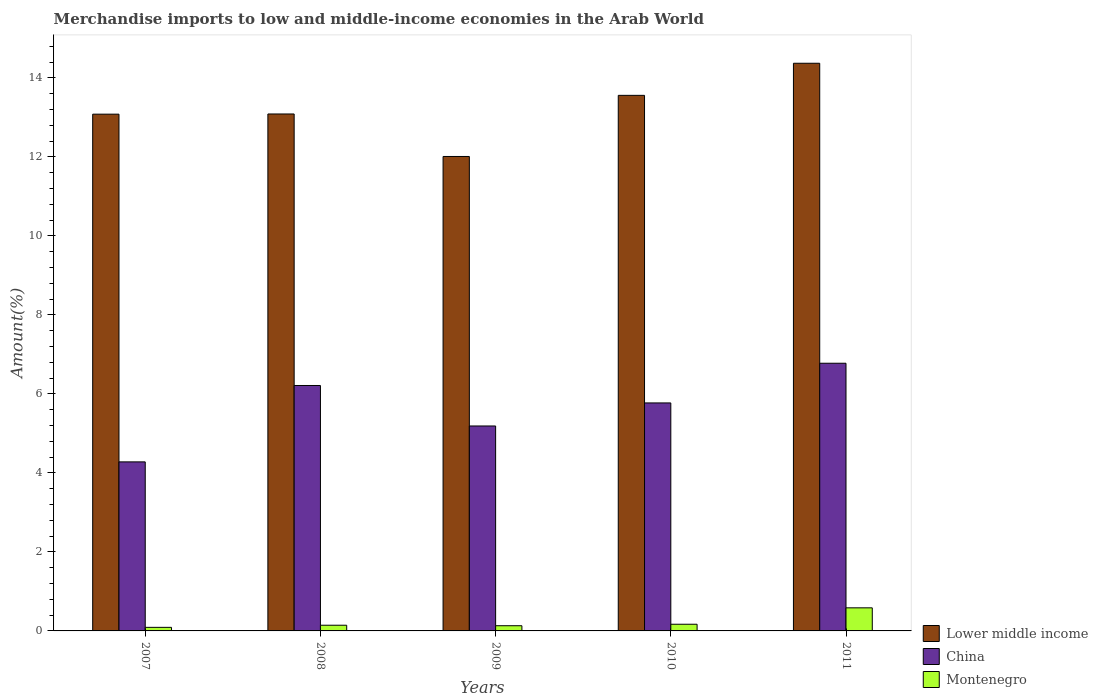How many different coloured bars are there?
Make the answer very short. 3. How many groups of bars are there?
Keep it short and to the point. 5. Are the number of bars per tick equal to the number of legend labels?
Your response must be concise. Yes. Are the number of bars on each tick of the X-axis equal?
Your answer should be compact. Yes. What is the label of the 2nd group of bars from the left?
Offer a terse response. 2008. In how many cases, is the number of bars for a given year not equal to the number of legend labels?
Provide a succinct answer. 0. What is the percentage of amount earned from merchandise imports in China in 2011?
Give a very brief answer. 6.78. Across all years, what is the maximum percentage of amount earned from merchandise imports in Lower middle income?
Offer a terse response. 14.37. Across all years, what is the minimum percentage of amount earned from merchandise imports in China?
Keep it short and to the point. 4.28. In which year was the percentage of amount earned from merchandise imports in China minimum?
Provide a short and direct response. 2007. What is the total percentage of amount earned from merchandise imports in Montenegro in the graph?
Your answer should be very brief. 1.12. What is the difference between the percentage of amount earned from merchandise imports in Lower middle income in 2007 and that in 2009?
Make the answer very short. 1.07. What is the difference between the percentage of amount earned from merchandise imports in Montenegro in 2008 and the percentage of amount earned from merchandise imports in Lower middle income in 2009?
Offer a terse response. -11.86. What is the average percentage of amount earned from merchandise imports in China per year?
Make the answer very short. 5.64. In the year 2008, what is the difference between the percentage of amount earned from merchandise imports in Lower middle income and percentage of amount earned from merchandise imports in China?
Give a very brief answer. 6.87. What is the ratio of the percentage of amount earned from merchandise imports in Montenegro in 2007 to that in 2010?
Give a very brief answer. 0.54. Is the percentage of amount earned from merchandise imports in Lower middle income in 2009 less than that in 2011?
Provide a short and direct response. Yes. What is the difference between the highest and the second highest percentage of amount earned from merchandise imports in Montenegro?
Offer a terse response. 0.42. What is the difference between the highest and the lowest percentage of amount earned from merchandise imports in Lower middle income?
Offer a very short reply. 2.36. Is the sum of the percentage of amount earned from merchandise imports in Lower middle income in 2007 and 2011 greater than the maximum percentage of amount earned from merchandise imports in Montenegro across all years?
Give a very brief answer. Yes. What does the 3rd bar from the left in 2008 represents?
Provide a succinct answer. Montenegro. What does the 3rd bar from the right in 2011 represents?
Your answer should be very brief. Lower middle income. Are all the bars in the graph horizontal?
Provide a short and direct response. No. How many years are there in the graph?
Keep it short and to the point. 5. What is the difference between two consecutive major ticks on the Y-axis?
Keep it short and to the point. 2. Where does the legend appear in the graph?
Your answer should be compact. Bottom right. What is the title of the graph?
Your answer should be compact. Merchandise imports to low and middle-income economies in the Arab World. What is the label or title of the Y-axis?
Your response must be concise. Amount(%). What is the Amount(%) of Lower middle income in 2007?
Ensure brevity in your answer.  13.08. What is the Amount(%) in China in 2007?
Provide a short and direct response. 4.28. What is the Amount(%) in Montenegro in 2007?
Your answer should be compact. 0.09. What is the Amount(%) of Lower middle income in 2008?
Your response must be concise. 13.08. What is the Amount(%) of China in 2008?
Ensure brevity in your answer.  6.21. What is the Amount(%) in Montenegro in 2008?
Your response must be concise. 0.14. What is the Amount(%) in Lower middle income in 2009?
Provide a succinct answer. 12.01. What is the Amount(%) of China in 2009?
Give a very brief answer. 5.19. What is the Amount(%) in Montenegro in 2009?
Give a very brief answer. 0.13. What is the Amount(%) of Lower middle income in 2010?
Keep it short and to the point. 13.56. What is the Amount(%) of China in 2010?
Ensure brevity in your answer.  5.77. What is the Amount(%) in Montenegro in 2010?
Offer a terse response. 0.17. What is the Amount(%) of Lower middle income in 2011?
Provide a succinct answer. 14.37. What is the Amount(%) in China in 2011?
Keep it short and to the point. 6.78. What is the Amount(%) of Montenegro in 2011?
Your answer should be compact. 0.58. Across all years, what is the maximum Amount(%) in Lower middle income?
Your answer should be compact. 14.37. Across all years, what is the maximum Amount(%) in China?
Your response must be concise. 6.78. Across all years, what is the maximum Amount(%) of Montenegro?
Keep it short and to the point. 0.58. Across all years, what is the minimum Amount(%) of Lower middle income?
Ensure brevity in your answer.  12.01. Across all years, what is the minimum Amount(%) of China?
Your response must be concise. 4.28. Across all years, what is the minimum Amount(%) in Montenegro?
Provide a succinct answer. 0.09. What is the total Amount(%) of Lower middle income in the graph?
Keep it short and to the point. 66.1. What is the total Amount(%) of China in the graph?
Your answer should be compact. 28.22. What is the total Amount(%) in Montenegro in the graph?
Ensure brevity in your answer.  1.12. What is the difference between the Amount(%) of Lower middle income in 2007 and that in 2008?
Your answer should be very brief. -0. What is the difference between the Amount(%) of China in 2007 and that in 2008?
Keep it short and to the point. -1.93. What is the difference between the Amount(%) in Montenegro in 2007 and that in 2008?
Provide a succinct answer. -0.05. What is the difference between the Amount(%) in Lower middle income in 2007 and that in 2009?
Your response must be concise. 1.07. What is the difference between the Amount(%) in China in 2007 and that in 2009?
Provide a succinct answer. -0.91. What is the difference between the Amount(%) of Montenegro in 2007 and that in 2009?
Keep it short and to the point. -0.04. What is the difference between the Amount(%) of Lower middle income in 2007 and that in 2010?
Offer a very short reply. -0.48. What is the difference between the Amount(%) of China in 2007 and that in 2010?
Offer a terse response. -1.49. What is the difference between the Amount(%) in Montenegro in 2007 and that in 2010?
Offer a terse response. -0.08. What is the difference between the Amount(%) in Lower middle income in 2007 and that in 2011?
Your answer should be very brief. -1.29. What is the difference between the Amount(%) of China in 2007 and that in 2011?
Provide a short and direct response. -2.5. What is the difference between the Amount(%) of Montenegro in 2007 and that in 2011?
Make the answer very short. -0.49. What is the difference between the Amount(%) in Lower middle income in 2008 and that in 2009?
Your response must be concise. 1.08. What is the difference between the Amount(%) of Montenegro in 2008 and that in 2009?
Provide a succinct answer. 0.01. What is the difference between the Amount(%) in Lower middle income in 2008 and that in 2010?
Ensure brevity in your answer.  -0.47. What is the difference between the Amount(%) of China in 2008 and that in 2010?
Ensure brevity in your answer.  0.44. What is the difference between the Amount(%) in Montenegro in 2008 and that in 2010?
Your answer should be very brief. -0.02. What is the difference between the Amount(%) in Lower middle income in 2008 and that in 2011?
Provide a succinct answer. -1.28. What is the difference between the Amount(%) in China in 2008 and that in 2011?
Offer a terse response. -0.56. What is the difference between the Amount(%) in Montenegro in 2008 and that in 2011?
Your answer should be very brief. -0.44. What is the difference between the Amount(%) in Lower middle income in 2009 and that in 2010?
Give a very brief answer. -1.55. What is the difference between the Amount(%) in China in 2009 and that in 2010?
Offer a terse response. -0.58. What is the difference between the Amount(%) of Montenegro in 2009 and that in 2010?
Provide a short and direct response. -0.04. What is the difference between the Amount(%) in Lower middle income in 2009 and that in 2011?
Provide a succinct answer. -2.36. What is the difference between the Amount(%) in China in 2009 and that in 2011?
Give a very brief answer. -1.59. What is the difference between the Amount(%) of Montenegro in 2009 and that in 2011?
Offer a terse response. -0.45. What is the difference between the Amount(%) in Lower middle income in 2010 and that in 2011?
Offer a very short reply. -0.81. What is the difference between the Amount(%) of China in 2010 and that in 2011?
Offer a terse response. -1. What is the difference between the Amount(%) of Montenegro in 2010 and that in 2011?
Make the answer very short. -0.42. What is the difference between the Amount(%) in Lower middle income in 2007 and the Amount(%) in China in 2008?
Your answer should be compact. 6.87. What is the difference between the Amount(%) in Lower middle income in 2007 and the Amount(%) in Montenegro in 2008?
Offer a very short reply. 12.94. What is the difference between the Amount(%) of China in 2007 and the Amount(%) of Montenegro in 2008?
Make the answer very short. 4.13. What is the difference between the Amount(%) of Lower middle income in 2007 and the Amount(%) of China in 2009?
Offer a very short reply. 7.89. What is the difference between the Amount(%) in Lower middle income in 2007 and the Amount(%) in Montenegro in 2009?
Your response must be concise. 12.95. What is the difference between the Amount(%) of China in 2007 and the Amount(%) of Montenegro in 2009?
Make the answer very short. 4.15. What is the difference between the Amount(%) of Lower middle income in 2007 and the Amount(%) of China in 2010?
Provide a short and direct response. 7.31. What is the difference between the Amount(%) of Lower middle income in 2007 and the Amount(%) of Montenegro in 2010?
Your response must be concise. 12.91. What is the difference between the Amount(%) of China in 2007 and the Amount(%) of Montenegro in 2010?
Provide a short and direct response. 4.11. What is the difference between the Amount(%) of Lower middle income in 2007 and the Amount(%) of China in 2011?
Provide a succinct answer. 6.3. What is the difference between the Amount(%) of Lower middle income in 2007 and the Amount(%) of Montenegro in 2011?
Your response must be concise. 12.5. What is the difference between the Amount(%) of China in 2007 and the Amount(%) of Montenegro in 2011?
Your answer should be compact. 3.69. What is the difference between the Amount(%) of Lower middle income in 2008 and the Amount(%) of China in 2009?
Provide a succinct answer. 7.9. What is the difference between the Amount(%) of Lower middle income in 2008 and the Amount(%) of Montenegro in 2009?
Provide a succinct answer. 12.95. What is the difference between the Amount(%) in China in 2008 and the Amount(%) in Montenegro in 2009?
Provide a short and direct response. 6.08. What is the difference between the Amount(%) in Lower middle income in 2008 and the Amount(%) in China in 2010?
Your response must be concise. 7.31. What is the difference between the Amount(%) in Lower middle income in 2008 and the Amount(%) in Montenegro in 2010?
Provide a short and direct response. 12.92. What is the difference between the Amount(%) in China in 2008 and the Amount(%) in Montenegro in 2010?
Provide a succinct answer. 6.04. What is the difference between the Amount(%) of Lower middle income in 2008 and the Amount(%) of China in 2011?
Offer a terse response. 6.31. What is the difference between the Amount(%) of Lower middle income in 2008 and the Amount(%) of Montenegro in 2011?
Your response must be concise. 12.5. What is the difference between the Amount(%) in China in 2008 and the Amount(%) in Montenegro in 2011?
Make the answer very short. 5.63. What is the difference between the Amount(%) of Lower middle income in 2009 and the Amount(%) of China in 2010?
Keep it short and to the point. 6.24. What is the difference between the Amount(%) in Lower middle income in 2009 and the Amount(%) in Montenegro in 2010?
Offer a terse response. 11.84. What is the difference between the Amount(%) in China in 2009 and the Amount(%) in Montenegro in 2010?
Your answer should be compact. 5.02. What is the difference between the Amount(%) of Lower middle income in 2009 and the Amount(%) of China in 2011?
Offer a very short reply. 5.23. What is the difference between the Amount(%) of Lower middle income in 2009 and the Amount(%) of Montenegro in 2011?
Offer a terse response. 11.42. What is the difference between the Amount(%) of China in 2009 and the Amount(%) of Montenegro in 2011?
Your answer should be very brief. 4.6. What is the difference between the Amount(%) in Lower middle income in 2010 and the Amount(%) in China in 2011?
Your answer should be very brief. 6.78. What is the difference between the Amount(%) in Lower middle income in 2010 and the Amount(%) in Montenegro in 2011?
Your answer should be compact. 12.97. What is the difference between the Amount(%) in China in 2010 and the Amount(%) in Montenegro in 2011?
Keep it short and to the point. 5.19. What is the average Amount(%) of Lower middle income per year?
Your answer should be very brief. 13.22. What is the average Amount(%) of China per year?
Your answer should be compact. 5.64. What is the average Amount(%) of Montenegro per year?
Your response must be concise. 0.22. In the year 2007, what is the difference between the Amount(%) in Lower middle income and Amount(%) in China?
Provide a succinct answer. 8.8. In the year 2007, what is the difference between the Amount(%) in Lower middle income and Amount(%) in Montenegro?
Your answer should be very brief. 12.99. In the year 2007, what is the difference between the Amount(%) in China and Amount(%) in Montenegro?
Keep it short and to the point. 4.19. In the year 2008, what is the difference between the Amount(%) in Lower middle income and Amount(%) in China?
Offer a very short reply. 6.87. In the year 2008, what is the difference between the Amount(%) in Lower middle income and Amount(%) in Montenegro?
Offer a very short reply. 12.94. In the year 2008, what is the difference between the Amount(%) in China and Amount(%) in Montenegro?
Your answer should be very brief. 6.07. In the year 2009, what is the difference between the Amount(%) of Lower middle income and Amount(%) of China?
Ensure brevity in your answer.  6.82. In the year 2009, what is the difference between the Amount(%) in Lower middle income and Amount(%) in Montenegro?
Provide a succinct answer. 11.88. In the year 2009, what is the difference between the Amount(%) in China and Amount(%) in Montenegro?
Offer a terse response. 5.06. In the year 2010, what is the difference between the Amount(%) of Lower middle income and Amount(%) of China?
Offer a very short reply. 7.79. In the year 2010, what is the difference between the Amount(%) in Lower middle income and Amount(%) in Montenegro?
Give a very brief answer. 13.39. In the year 2010, what is the difference between the Amount(%) in China and Amount(%) in Montenegro?
Give a very brief answer. 5.6. In the year 2011, what is the difference between the Amount(%) of Lower middle income and Amount(%) of China?
Your response must be concise. 7.59. In the year 2011, what is the difference between the Amount(%) in Lower middle income and Amount(%) in Montenegro?
Ensure brevity in your answer.  13.78. In the year 2011, what is the difference between the Amount(%) in China and Amount(%) in Montenegro?
Offer a terse response. 6.19. What is the ratio of the Amount(%) in Lower middle income in 2007 to that in 2008?
Keep it short and to the point. 1. What is the ratio of the Amount(%) of China in 2007 to that in 2008?
Your answer should be compact. 0.69. What is the ratio of the Amount(%) in Montenegro in 2007 to that in 2008?
Provide a short and direct response. 0.63. What is the ratio of the Amount(%) in Lower middle income in 2007 to that in 2009?
Provide a short and direct response. 1.09. What is the ratio of the Amount(%) in China in 2007 to that in 2009?
Offer a terse response. 0.82. What is the ratio of the Amount(%) of Montenegro in 2007 to that in 2009?
Offer a terse response. 0.69. What is the ratio of the Amount(%) in Lower middle income in 2007 to that in 2010?
Provide a succinct answer. 0.96. What is the ratio of the Amount(%) of China in 2007 to that in 2010?
Provide a short and direct response. 0.74. What is the ratio of the Amount(%) in Montenegro in 2007 to that in 2010?
Make the answer very short. 0.54. What is the ratio of the Amount(%) of Lower middle income in 2007 to that in 2011?
Provide a short and direct response. 0.91. What is the ratio of the Amount(%) in China in 2007 to that in 2011?
Keep it short and to the point. 0.63. What is the ratio of the Amount(%) of Montenegro in 2007 to that in 2011?
Give a very brief answer. 0.15. What is the ratio of the Amount(%) in Lower middle income in 2008 to that in 2009?
Provide a short and direct response. 1.09. What is the ratio of the Amount(%) of China in 2008 to that in 2009?
Make the answer very short. 1.2. What is the ratio of the Amount(%) in Montenegro in 2008 to that in 2009?
Your answer should be compact. 1.1. What is the ratio of the Amount(%) in Lower middle income in 2008 to that in 2010?
Provide a succinct answer. 0.97. What is the ratio of the Amount(%) of China in 2008 to that in 2010?
Provide a succinct answer. 1.08. What is the ratio of the Amount(%) in Montenegro in 2008 to that in 2010?
Offer a terse response. 0.85. What is the ratio of the Amount(%) of Lower middle income in 2008 to that in 2011?
Offer a terse response. 0.91. What is the ratio of the Amount(%) in China in 2008 to that in 2011?
Offer a terse response. 0.92. What is the ratio of the Amount(%) in Montenegro in 2008 to that in 2011?
Keep it short and to the point. 0.25. What is the ratio of the Amount(%) in Lower middle income in 2009 to that in 2010?
Offer a terse response. 0.89. What is the ratio of the Amount(%) in China in 2009 to that in 2010?
Offer a terse response. 0.9. What is the ratio of the Amount(%) in Montenegro in 2009 to that in 2010?
Your response must be concise. 0.78. What is the ratio of the Amount(%) of Lower middle income in 2009 to that in 2011?
Provide a succinct answer. 0.84. What is the ratio of the Amount(%) of China in 2009 to that in 2011?
Ensure brevity in your answer.  0.77. What is the ratio of the Amount(%) in Montenegro in 2009 to that in 2011?
Keep it short and to the point. 0.23. What is the ratio of the Amount(%) in Lower middle income in 2010 to that in 2011?
Make the answer very short. 0.94. What is the ratio of the Amount(%) in China in 2010 to that in 2011?
Give a very brief answer. 0.85. What is the ratio of the Amount(%) of Montenegro in 2010 to that in 2011?
Give a very brief answer. 0.29. What is the difference between the highest and the second highest Amount(%) in Lower middle income?
Give a very brief answer. 0.81. What is the difference between the highest and the second highest Amount(%) of China?
Give a very brief answer. 0.56. What is the difference between the highest and the second highest Amount(%) of Montenegro?
Offer a very short reply. 0.42. What is the difference between the highest and the lowest Amount(%) of Lower middle income?
Your answer should be compact. 2.36. What is the difference between the highest and the lowest Amount(%) in China?
Offer a very short reply. 2.5. What is the difference between the highest and the lowest Amount(%) in Montenegro?
Make the answer very short. 0.49. 